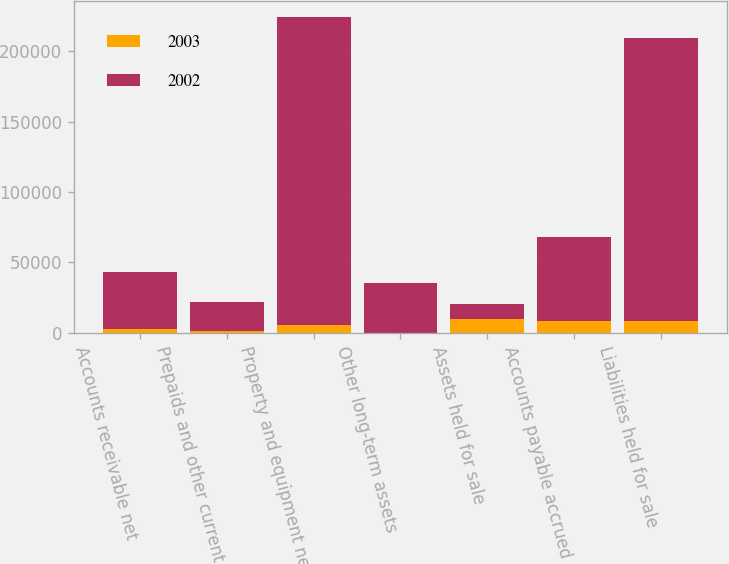Convert chart. <chart><loc_0><loc_0><loc_500><loc_500><stacked_bar_chart><ecel><fcel>Accounts receivable net<fcel>Prepaids and other current<fcel>Property and equipment net<fcel>Other long-term assets<fcel>Assets held for sale<fcel>Accounts payable accrued<fcel>Liabilities held for sale<nl><fcel>2003<fcel>2982<fcel>1554<fcel>5532<fcel>51<fcel>10119<fcel>8416<fcel>8416<nl><fcel>2002<fcel>40069<fcel>20161<fcel>218670<fcel>35305<fcel>10119<fcel>59324<fcel>200696<nl></chart> 